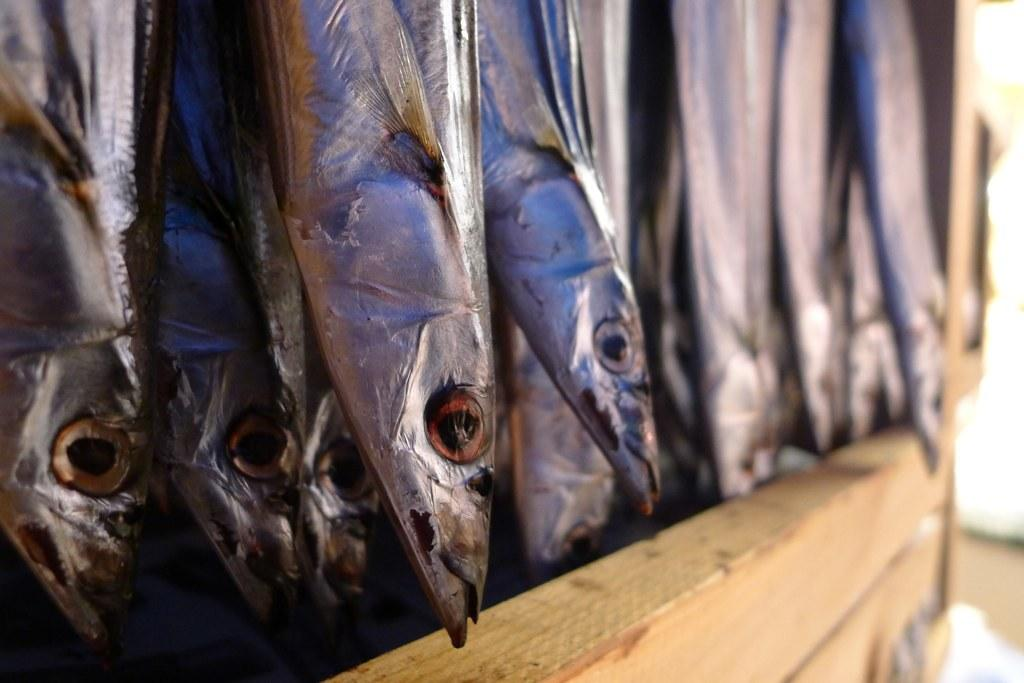What type of material is the wooden object made of in the image? The wooden object in the image is made of wood. What other living creatures can be seen in the image? There are fish in the image. How does the memory of the fish affect the wooden object in the image? There is no indication of memory or any emotional connection between the fish and the wooden object in the image. 